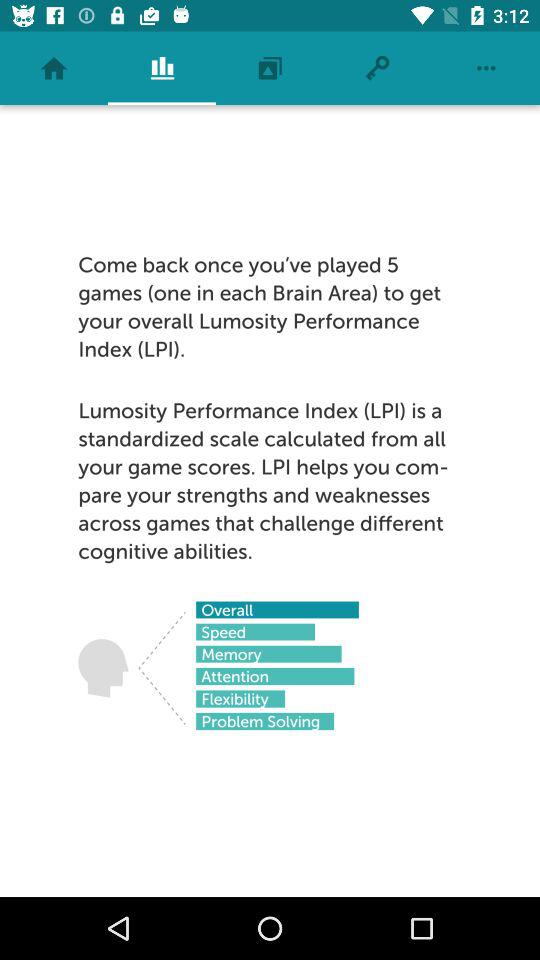What is the "Lumosity Performance Index"? The "Lumosity Performance Index" is a standardized scale. 